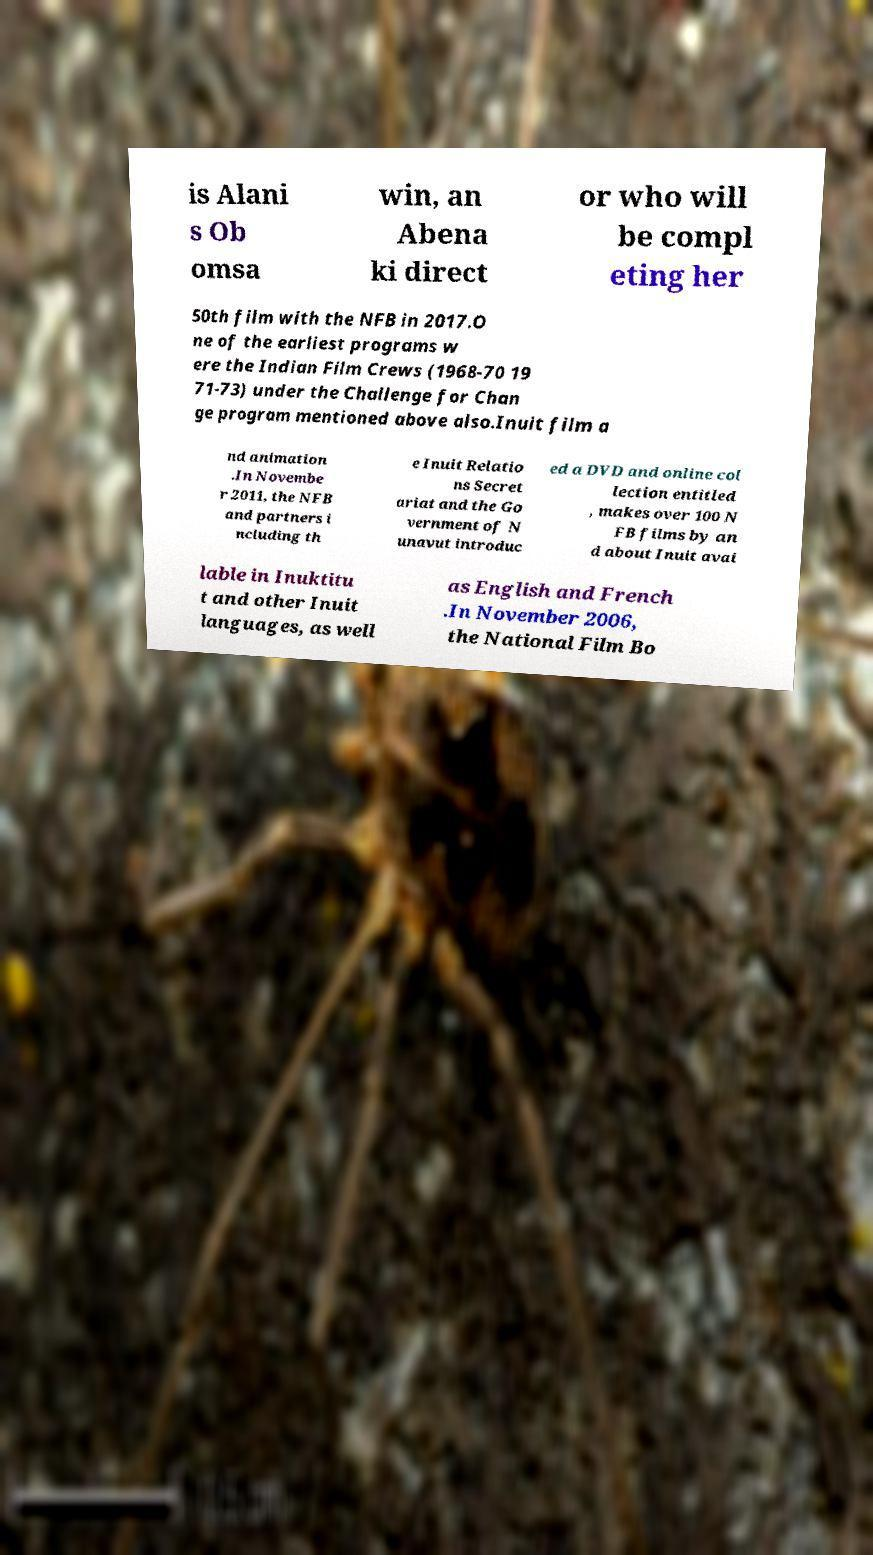Could you assist in decoding the text presented in this image and type it out clearly? is Alani s Ob omsa win, an Abena ki direct or who will be compl eting her 50th film with the NFB in 2017.O ne of the earliest programs w ere the Indian Film Crews (1968-70 19 71-73) under the Challenge for Chan ge program mentioned above also.Inuit film a nd animation .In Novembe r 2011, the NFB and partners i ncluding th e Inuit Relatio ns Secret ariat and the Go vernment of N unavut introduc ed a DVD and online col lection entitled , makes over 100 N FB films by an d about Inuit avai lable in Inuktitu t and other Inuit languages, as well as English and French .In November 2006, the National Film Bo 